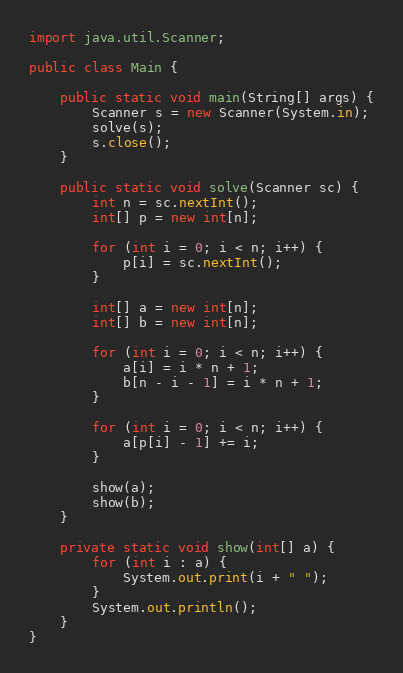Convert code to text. <code><loc_0><loc_0><loc_500><loc_500><_Java_>import java.util.Scanner;

public class Main {

	public static void main(String[] args) {
		Scanner s = new Scanner(System.in);
		solve(s);
		s.close();
	}

	public static void solve(Scanner sc) {
		int n = sc.nextInt();
		int[] p = new int[n];

		for (int i = 0; i < n; i++) {
			p[i] = sc.nextInt();
		}

		int[] a = new int[n];
		int[] b = new int[n];

		for (int i = 0; i < n; i++) {
			a[i] = i * n + 1;
			b[n - i - 1] = i * n + 1;
		}

		for (int i = 0; i < n; i++) {
			a[p[i] - 1] += i;
		}

		show(a);
		show(b);
	}

	private static void show(int[] a) {
		for (int i : a) {
			System.out.print(i + " ");
		}
		System.out.println();
	}
}</code> 